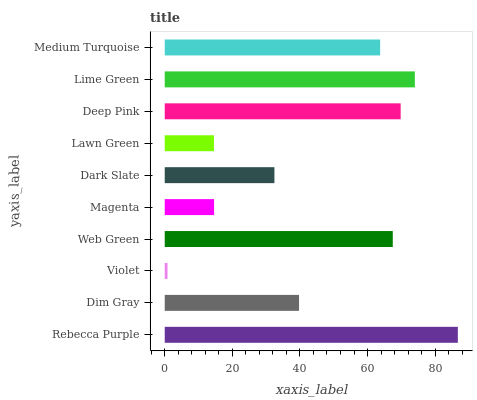Is Violet the minimum?
Answer yes or no. Yes. Is Rebecca Purple the maximum?
Answer yes or no. Yes. Is Dim Gray the minimum?
Answer yes or no. No. Is Dim Gray the maximum?
Answer yes or no. No. Is Rebecca Purple greater than Dim Gray?
Answer yes or no. Yes. Is Dim Gray less than Rebecca Purple?
Answer yes or no. Yes. Is Dim Gray greater than Rebecca Purple?
Answer yes or no. No. Is Rebecca Purple less than Dim Gray?
Answer yes or no. No. Is Medium Turquoise the high median?
Answer yes or no. Yes. Is Dim Gray the low median?
Answer yes or no. Yes. Is Dark Slate the high median?
Answer yes or no. No. Is Web Green the low median?
Answer yes or no. No. 